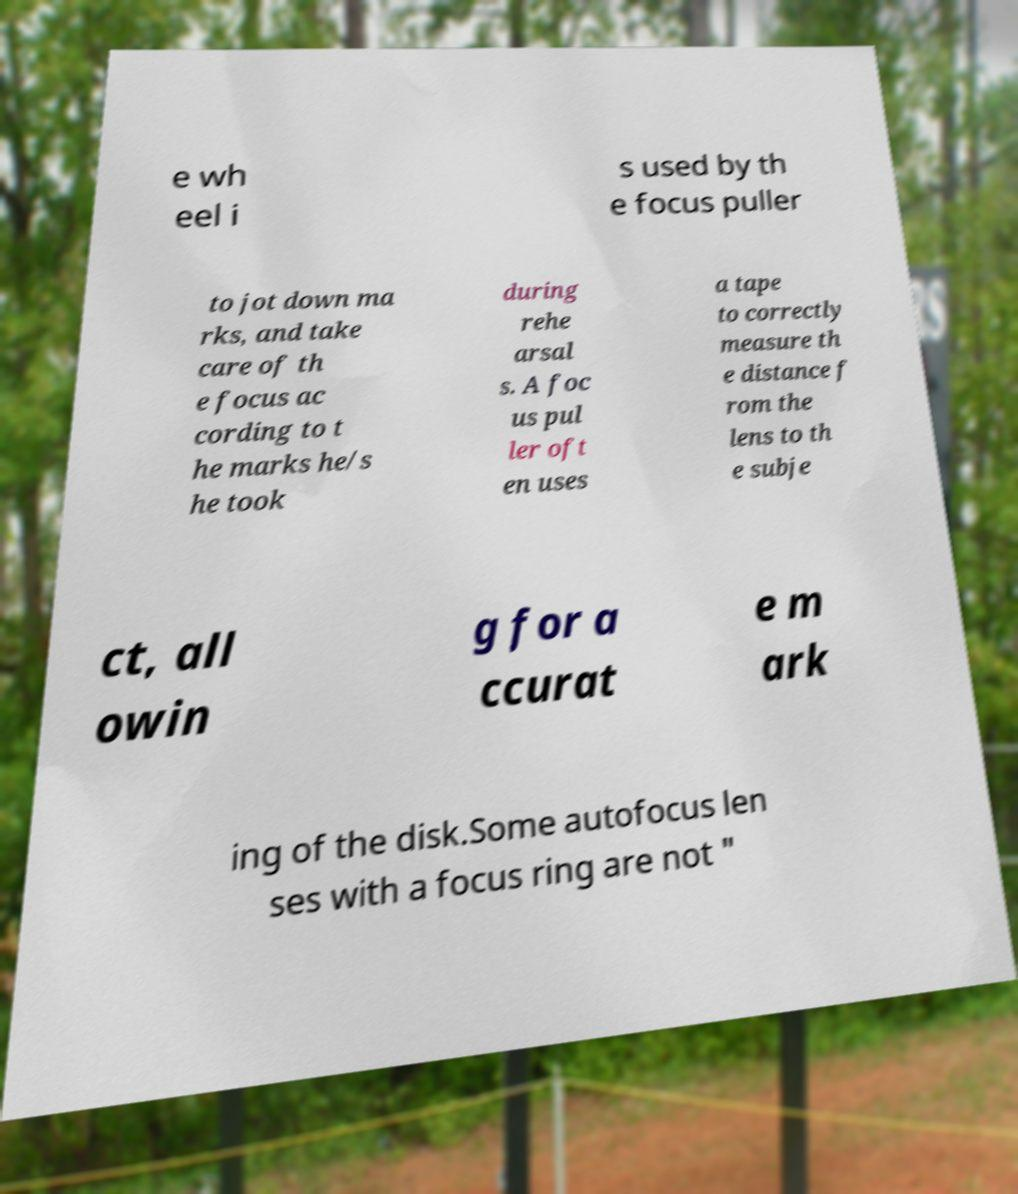Could you assist in decoding the text presented in this image and type it out clearly? e wh eel i s used by th e focus puller to jot down ma rks, and take care of th e focus ac cording to t he marks he/s he took during rehe arsal s. A foc us pul ler oft en uses a tape to correctly measure th e distance f rom the lens to th e subje ct, all owin g for a ccurat e m ark ing of the disk.Some autofocus len ses with a focus ring are not " 